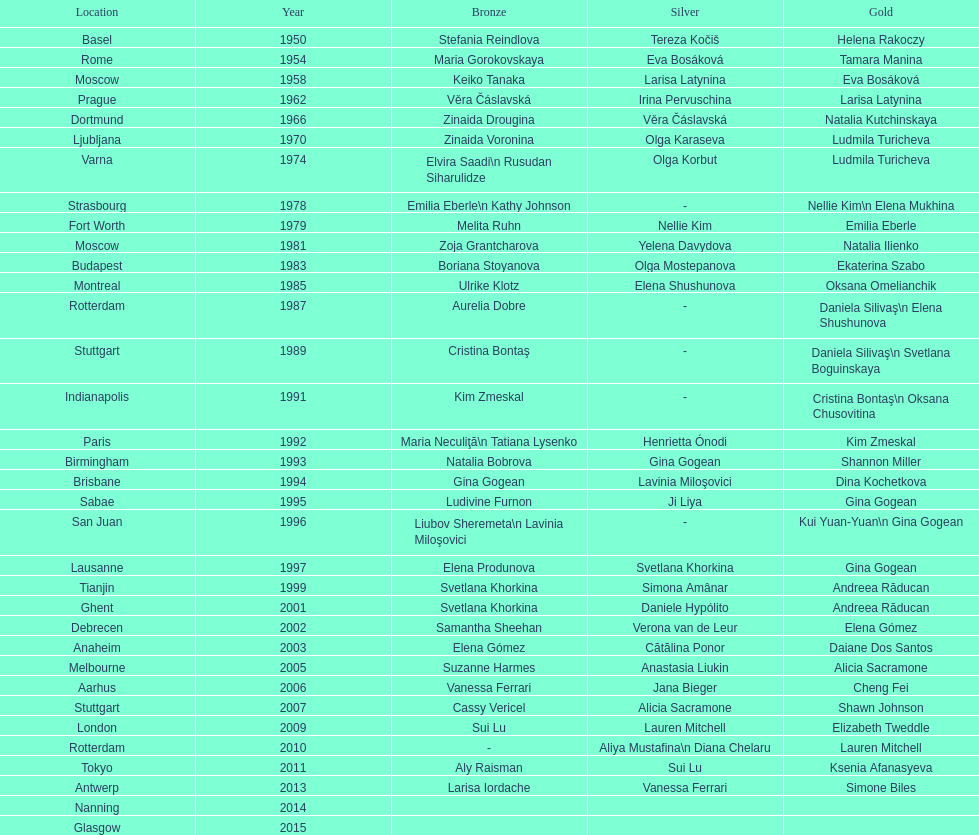What is the number of times a brazilian has won a medal? 2. 